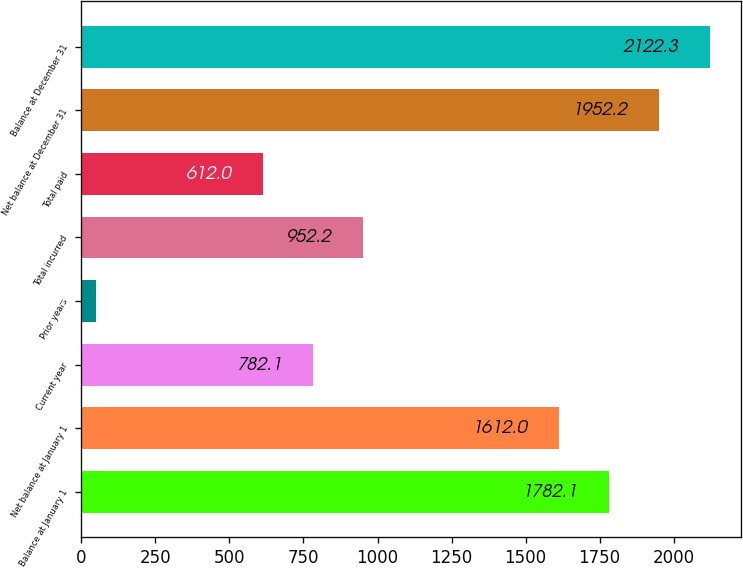<chart> <loc_0><loc_0><loc_500><loc_500><bar_chart><fcel>Balance at January 1<fcel>Net balance at January 1<fcel>Current year<fcel>Prior years<fcel>Total incurred<fcel>Total paid<fcel>Net balance at December 31<fcel>Balance at December 31<nl><fcel>1782.1<fcel>1612<fcel>782.1<fcel>48<fcel>952.2<fcel>612<fcel>1952.2<fcel>2122.3<nl></chart> 